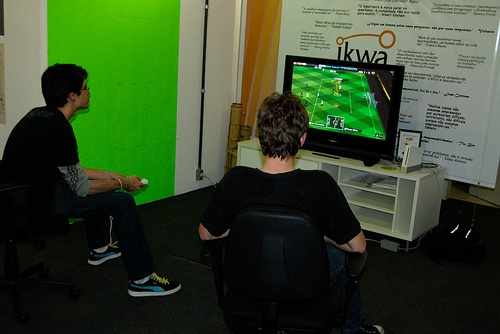Describe the objects in this image and their specific colors. I can see people in black, maroon, and gray tones, people in black, gray, and tan tones, tv in black, green, and darkgreen tones, and remote in black, darkgray, tan, and gray tones in this image. 